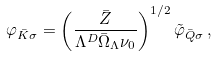<formula> <loc_0><loc_0><loc_500><loc_500>\varphi _ { \bar { K } \sigma } = \left ( \frac { \bar { Z } } { \Lambda ^ { D } \bar { \Omega } _ { \Lambda } \nu _ { 0 } } \right ) ^ { 1 / 2 } \tilde { \varphi } _ { \bar { Q } \sigma } \, ,</formula> 